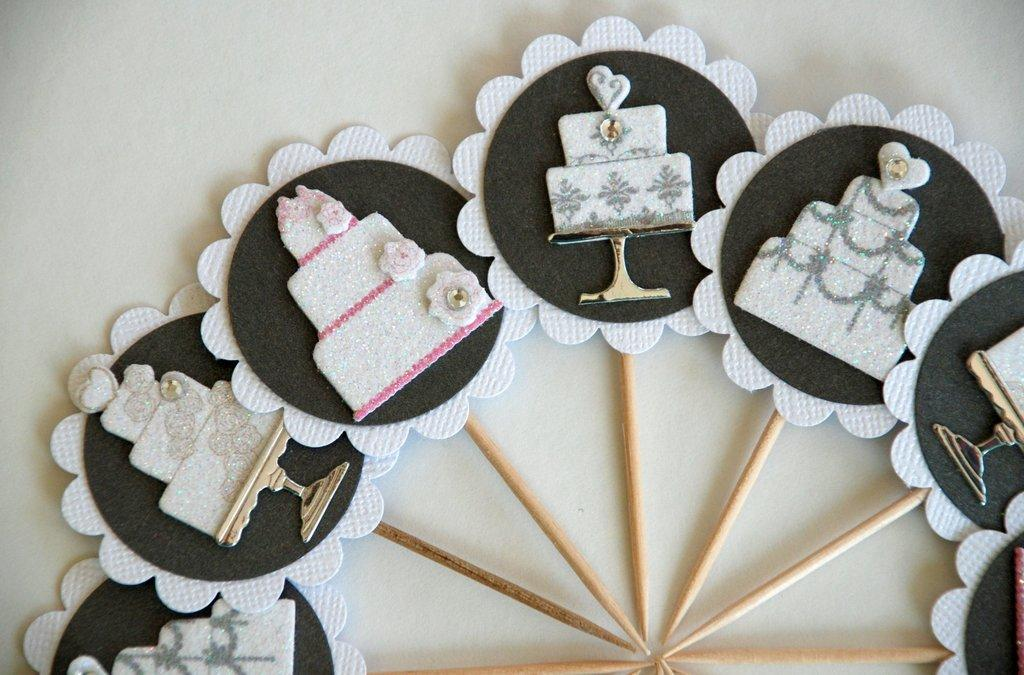What type of craft is depicted in the image? There is a paper craft in the image. What does the paper craft resemble? The paper craft resembles cakes. What is used to hold the paper craft together or to support it? Toothpicks are present in the image. What type of cream is used to decorate the quilt in the image? There is no quilt or cream present in the image; it features a paper craft that resembles cakes and toothpicks. 